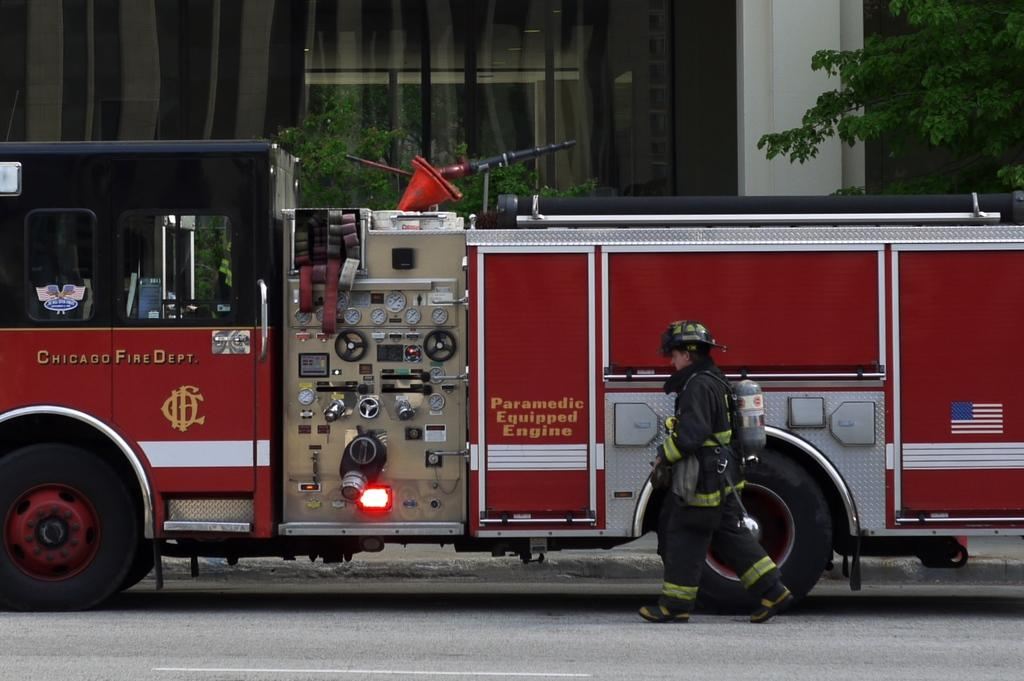What can be seen in the image? There is a person in the image. What is the person wearing? The person is wearing a helmet. What is the person carrying on their back? The person is carrying a cylinder on their back. What else is present in the image? There is a vehicle in the image, and it is behind the person. What can be seen in the background of the image? There are trees and a building in the background of the image. What type of ray can be seen swimming in the background of the image? There is no ray present in the image; it features a person, a vehicle, and a background with trees and a building. 